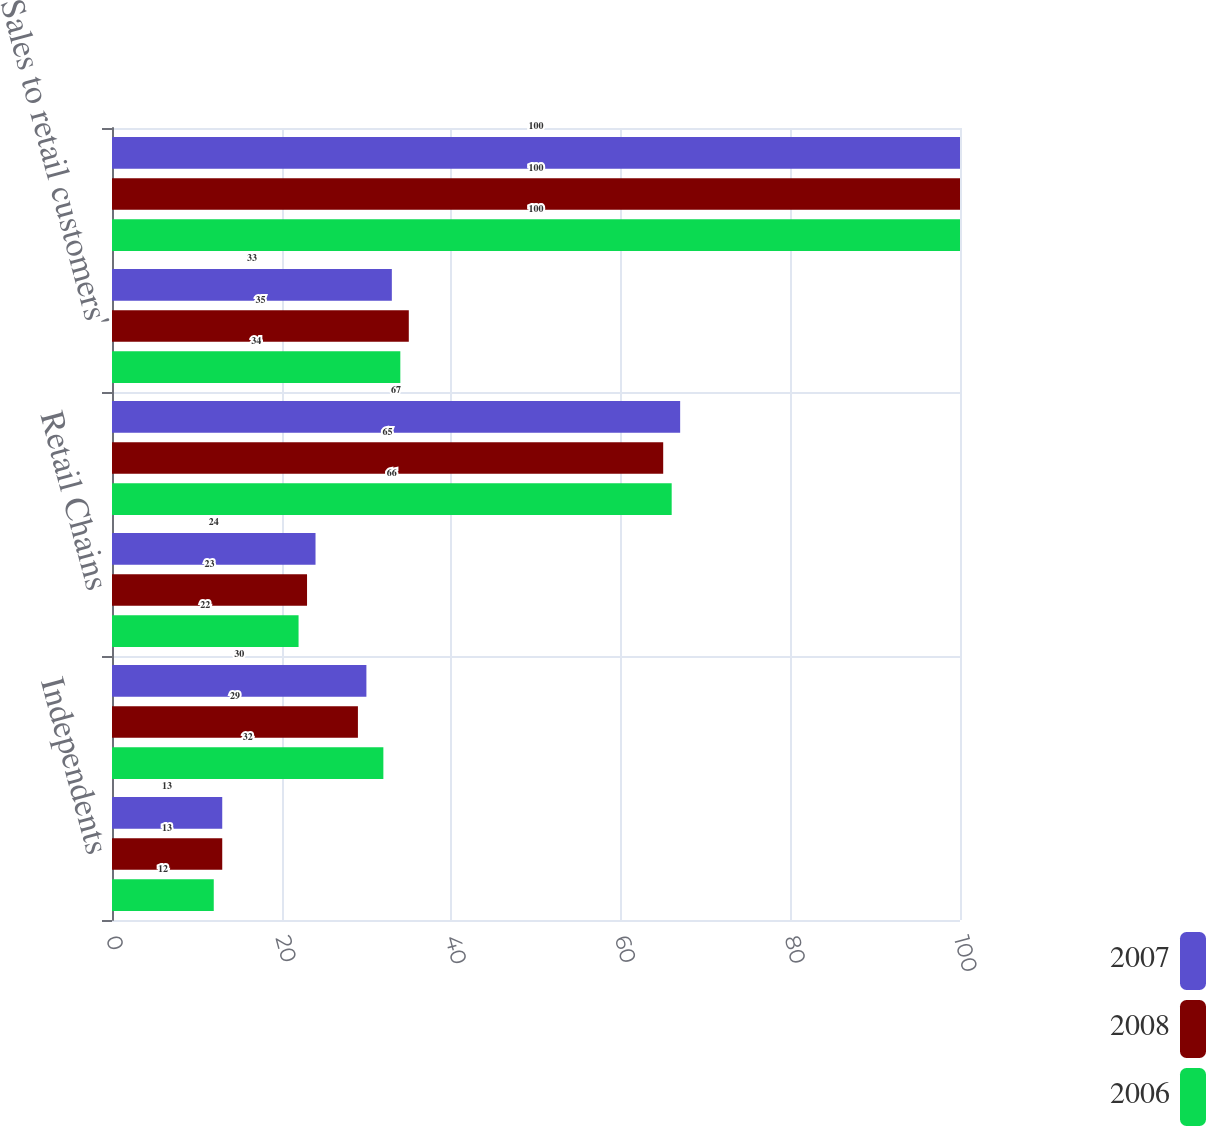Convert chart. <chart><loc_0><loc_0><loc_500><loc_500><stacked_bar_chart><ecel><fcel>Independents<fcel>Institutions<fcel>Retail Chains<fcel>Subtotal<fcel>Sales to retail customers'<fcel>Total<nl><fcel>2007<fcel>13<fcel>30<fcel>24<fcel>67<fcel>33<fcel>100<nl><fcel>2008<fcel>13<fcel>29<fcel>23<fcel>65<fcel>35<fcel>100<nl><fcel>2006<fcel>12<fcel>32<fcel>22<fcel>66<fcel>34<fcel>100<nl></chart> 